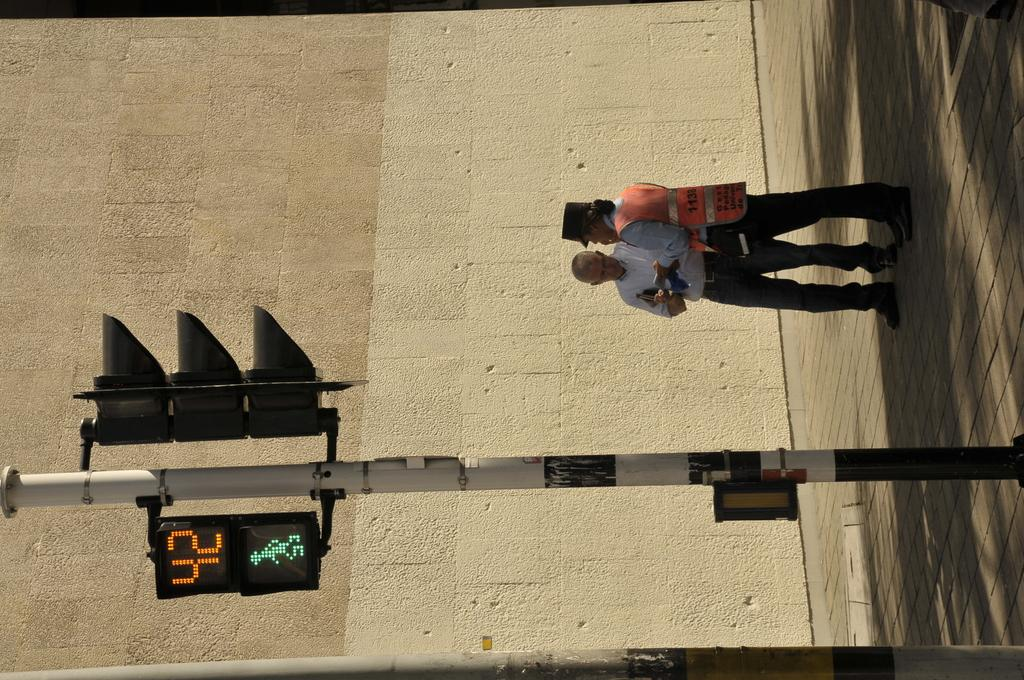<image>
Create a compact narrative representing the image presented. Man talking with a crossing guard on the side of a street; and a traffic light that has 42 seconds and it says Walk. 